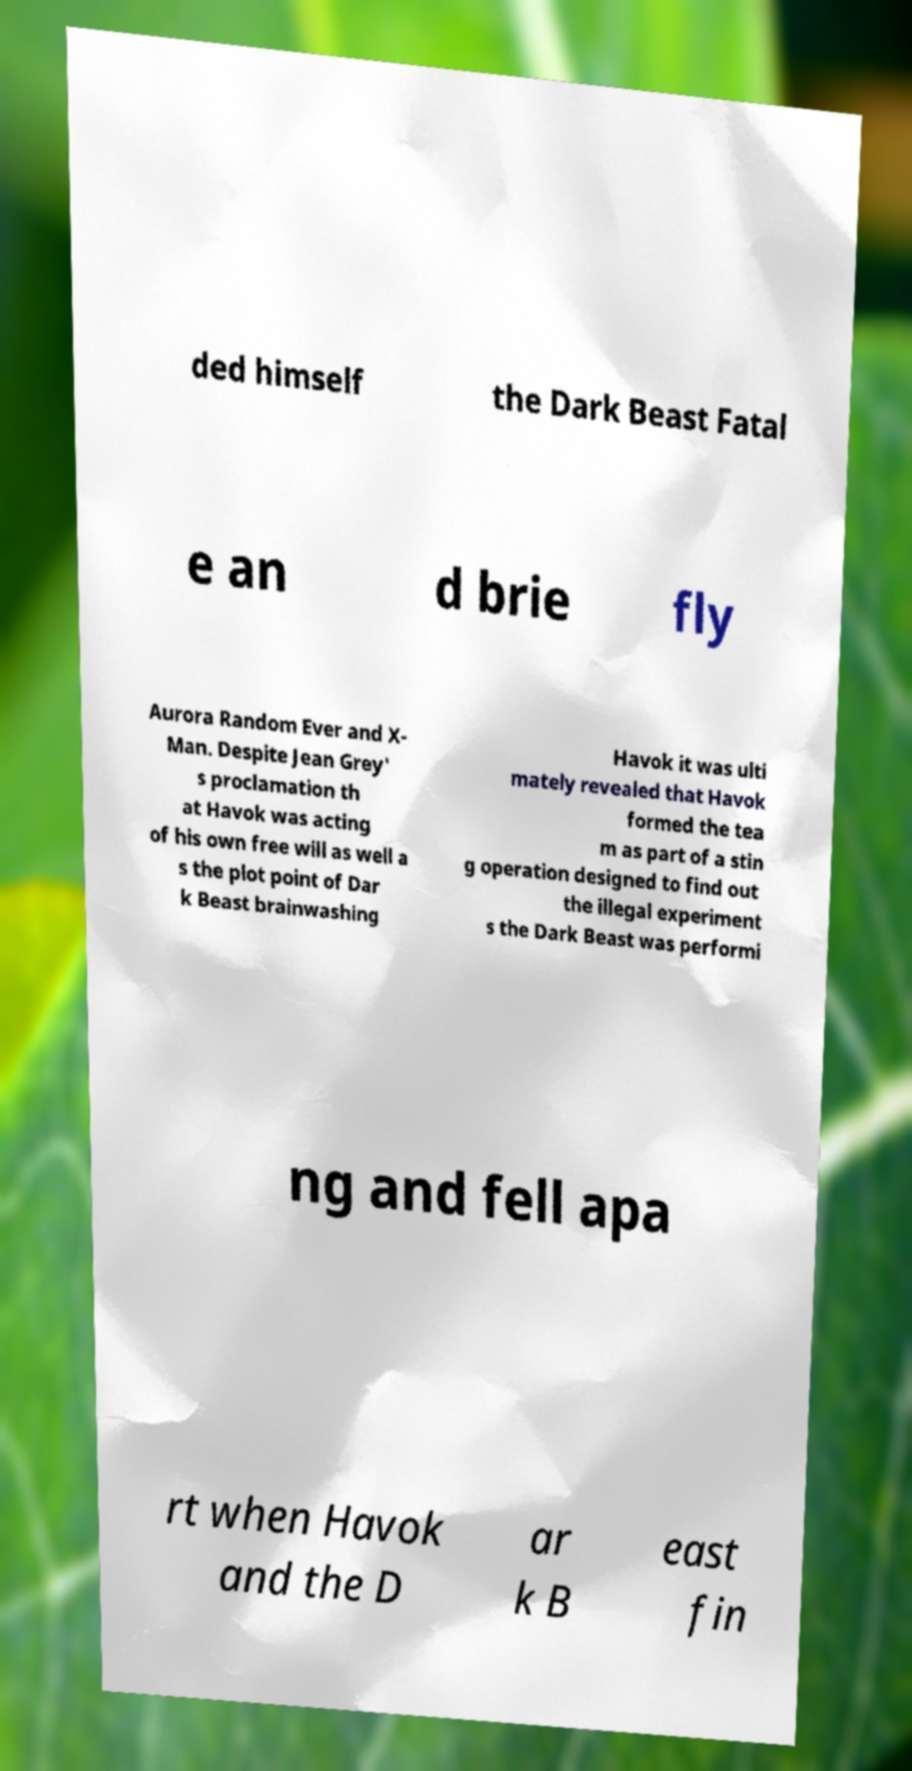There's text embedded in this image that I need extracted. Can you transcribe it verbatim? ded himself the Dark Beast Fatal e an d brie fly Aurora Random Ever and X- Man. Despite Jean Grey' s proclamation th at Havok was acting of his own free will as well a s the plot point of Dar k Beast brainwashing Havok it was ulti mately revealed that Havok formed the tea m as part of a stin g operation designed to find out the illegal experiment s the Dark Beast was performi ng and fell apa rt when Havok and the D ar k B east fin 